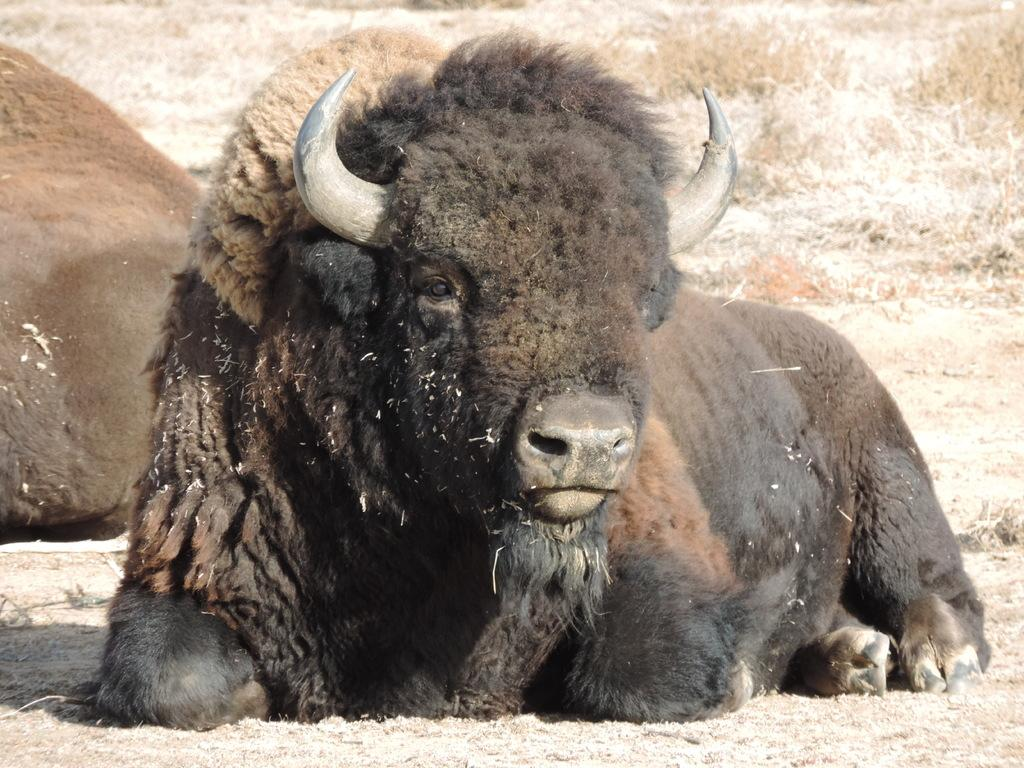What animals are present in the image? There are two bulls in the image. What position are the bulls in? The bulls are sitting on the ground. What type of vegetation can be seen in the background of the image? There is grass visible in the background of the image. Can you see any dinosaurs in the image? No, there are no dinosaurs present in the image. What type of pencil is the bull holding in the image? There is no pencil visible in the image, and the bulls are not holding anything. 